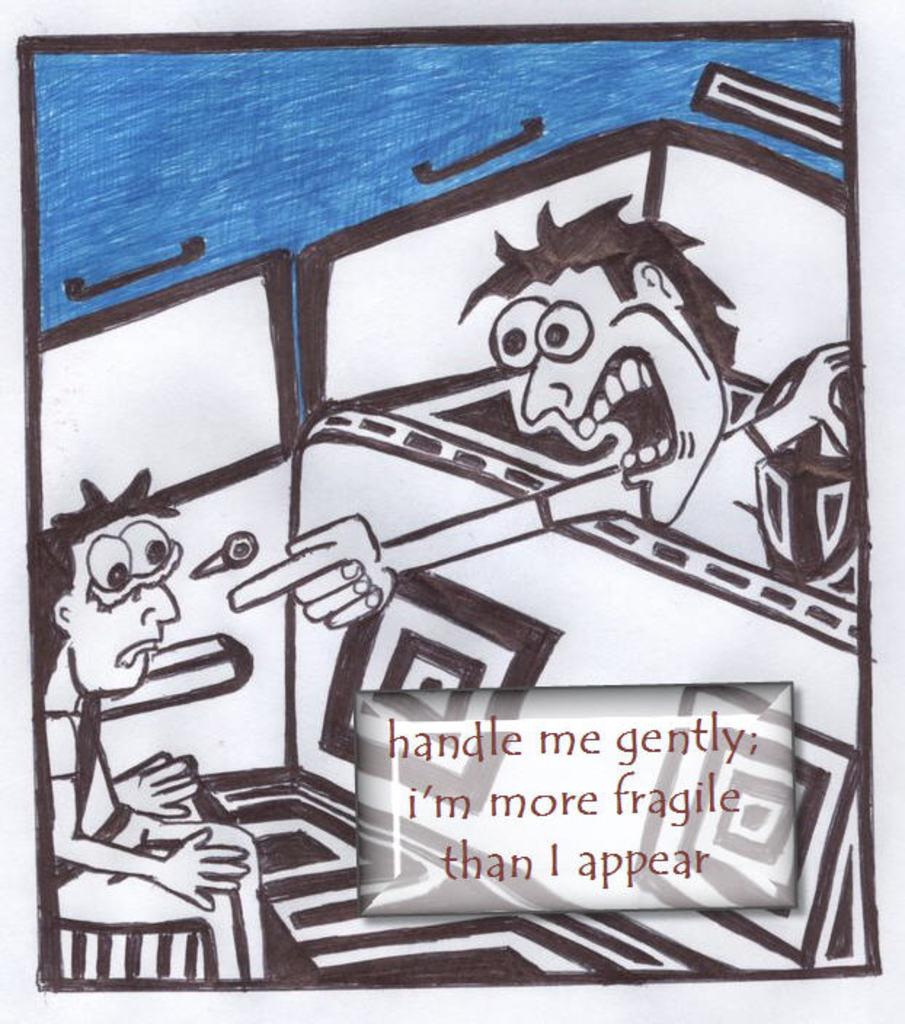Provide a one-sentence caption for the provided image. A cartoon of a man pointing at another man and telling him that he is fragile. 